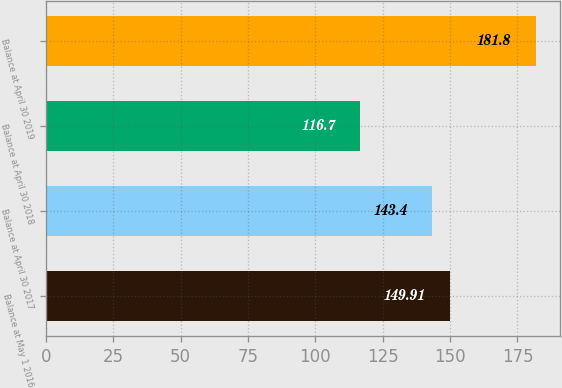Convert chart. <chart><loc_0><loc_0><loc_500><loc_500><bar_chart><fcel>Balance at May 1 2016<fcel>Balance at April 30 2017<fcel>Balance at April 30 2018<fcel>Balance at April 30 2019<nl><fcel>149.91<fcel>143.4<fcel>116.7<fcel>181.8<nl></chart> 